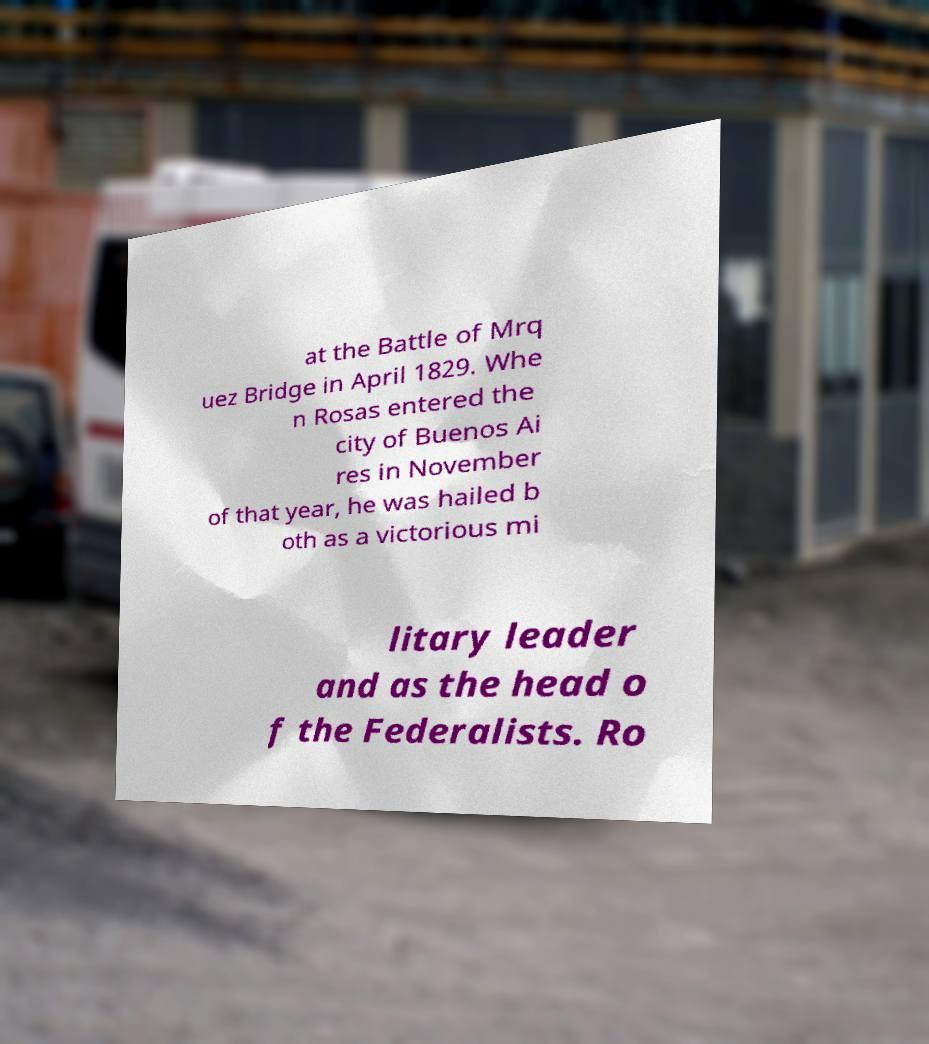What messages or text are displayed in this image? I need them in a readable, typed format. at the Battle of Mrq uez Bridge in April 1829. Whe n Rosas entered the city of Buenos Ai res in November of that year, he was hailed b oth as a victorious mi litary leader and as the head o f the Federalists. Ro 